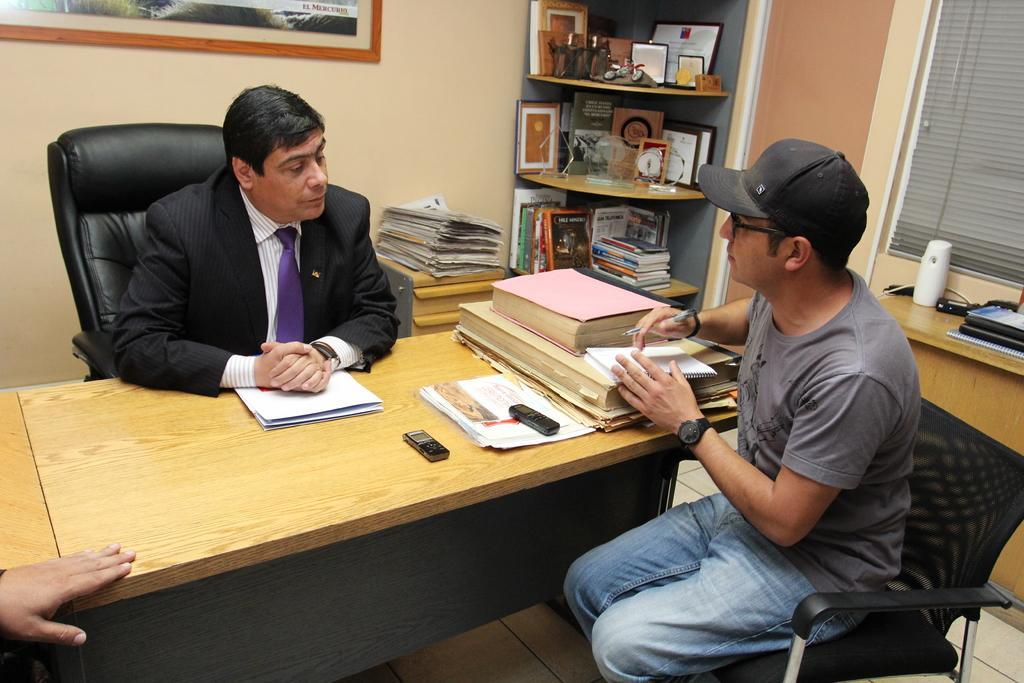Describe this image in one or two sentences. This image is clicked inside a room. There is a table and two chairs. People are sitting on two chairs. On the table that are mobile phones, papers, books. On the right side there is a window blind. There is a shelf in the middle. There are Shields and brooks in that shelves. There is a photo frame on the top. 